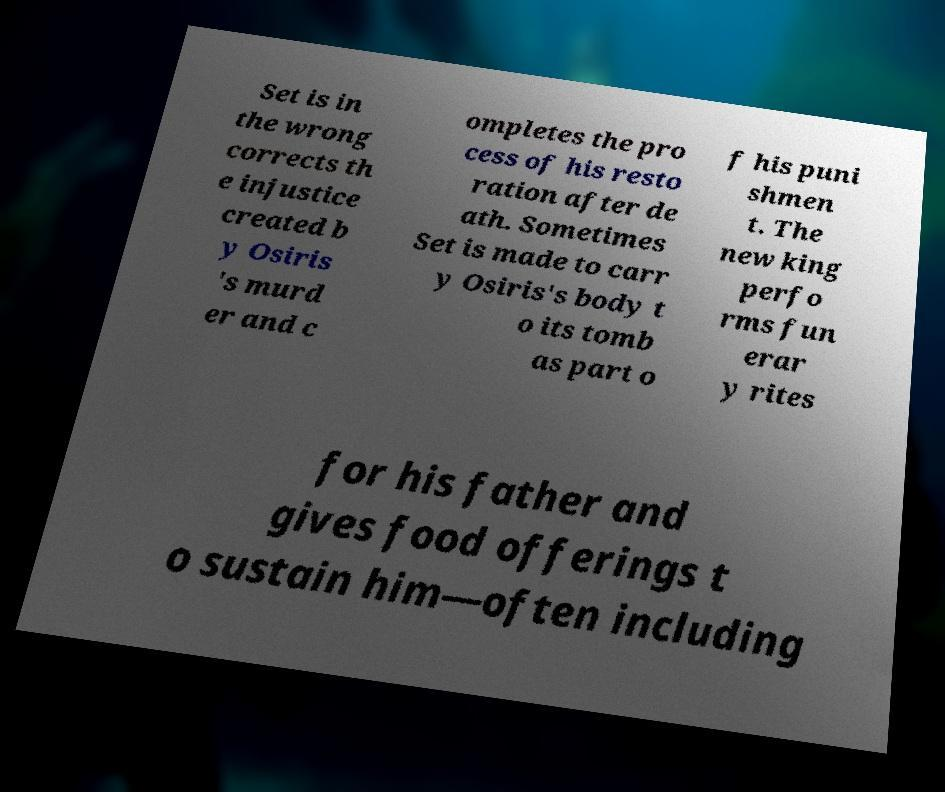For documentation purposes, I need the text within this image transcribed. Could you provide that? Set is in the wrong corrects th e injustice created b y Osiris 's murd er and c ompletes the pro cess of his resto ration after de ath. Sometimes Set is made to carr y Osiris's body t o its tomb as part o f his puni shmen t. The new king perfo rms fun erar y rites for his father and gives food offerings t o sustain him—often including 